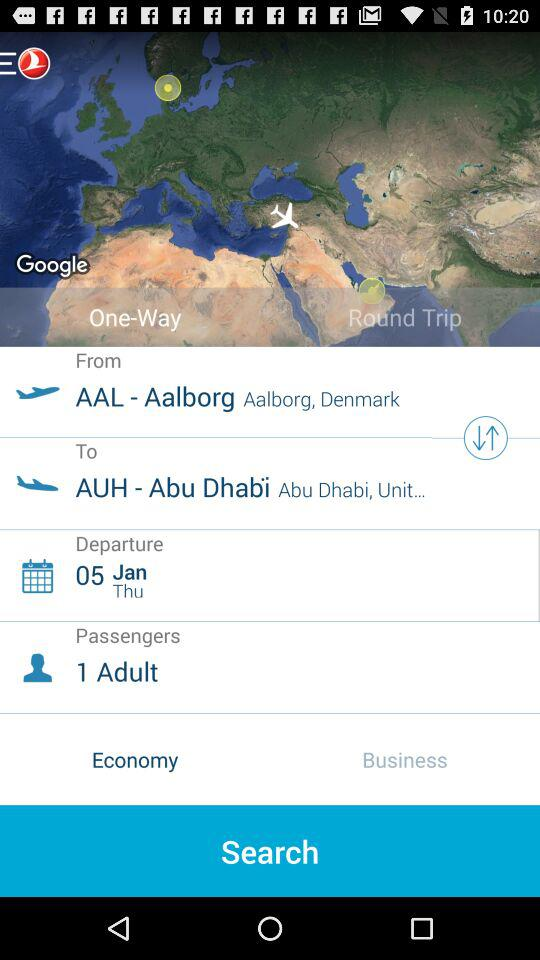What is the source of flight? The source of the flight is "Aalborg, Denmark". 